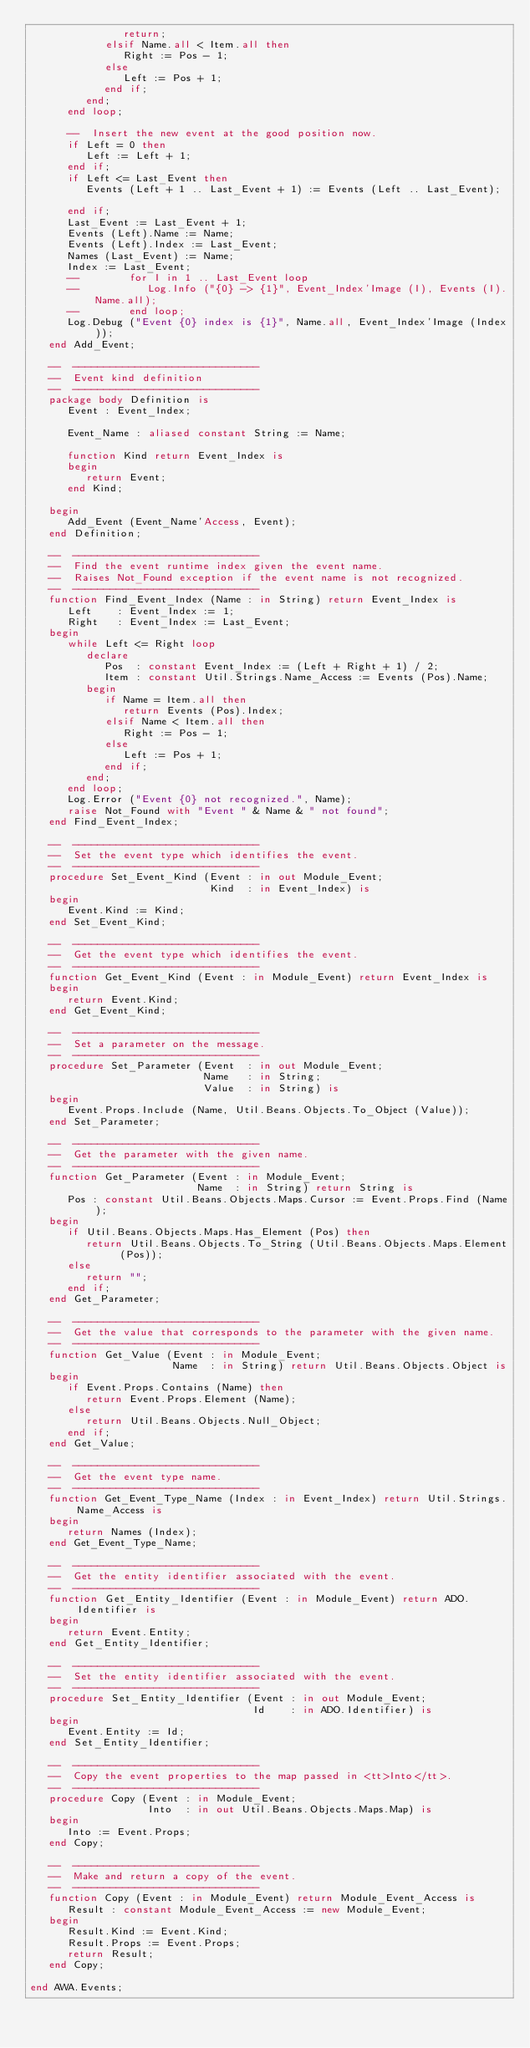<code> <loc_0><loc_0><loc_500><loc_500><_Ada_>               return;
            elsif Name.all < Item.all then
               Right := Pos - 1;
            else
               Left := Pos + 1;
            end if;
         end;
      end loop;

      --  Insert the new event at the good position now.
      if Left = 0 then
         Left := Left + 1;
      end if;
      if Left <= Last_Event then
         Events (Left + 1 .. Last_Event + 1) := Events (Left .. Last_Event);

      end if;
      Last_Event := Last_Event + 1;
      Events (Left).Name := Name;
      Events (Left).Index := Last_Event;
      Names (Last_Event) := Name;
      Index := Last_Event;
      --        for I in 1 .. Last_Event loop
      --           Log.Info ("{0} -> {1}", Event_Index'Image (I), Events (I).Name.all);
      --        end loop;
      Log.Debug ("Event {0} index is {1}", Name.all, Event_Index'Image (Index));
   end Add_Event;

   --  ------------------------------
   --  Event kind definition
   --  ------------------------------
   package body Definition is
      Event : Event_Index;

      Event_Name : aliased constant String := Name;

      function Kind return Event_Index is
      begin
         return Event;
      end Kind;

   begin
      Add_Event (Event_Name'Access, Event);
   end Definition;

   --  ------------------------------
   --  Find the event runtime index given the event name.
   --  Raises Not_Found exception if the event name is not recognized.
   --  ------------------------------
   function Find_Event_Index (Name : in String) return Event_Index is
      Left    : Event_Index := 1;
      Right   : Event_Index := Last_Event;
   begin
      while Left <= Right loop
         declare
            Pos  : constant Event_Index := (Left + Right + 1) / 2;
            Item : constant Util.Strings.Name_Access := Events (Pos).Name;
         begin
            if Name = Item.all then
               return Events (Pos).Index;
            elsif Name < Item.all then
               Right := Pos - 1;
            else
               Left := Pos + 1;
            end if;
         end;
      end loop;
      Log.Error ("Event {0} not recognized.", Name);
      raise Not_Found with "Event " & Name & " not found";
   end Find_Event_Index;

   --  ------------------------------
   --  Set the event type which identifies the event.
   --  ------------------------------
   procedure Set_Event_Kind (Event : in out Module_Event;
                             Kind  : in Event_Index) is
   begin
      Event.Kind := Kind;
   end Set_Event_Kind;

   --  ------------------------------
   --  Get the event type which identifies the event.
   --  ------------------------------
   function Get_Event_Kind (Event : in Module_Event) return Event_Index is
   begin
      return Event.Kind;
   end Get_Event_Kind;

   --  ------------------------------
   --  Set a parameter on the message.
   --  ------------------------------
   procedure Set_Parameter (Event  : in out Module_Event;
                            Name   : in String;
                            Value  : in String) is
   begin
      Event.Props.Include (Name, Util.Beans.Objects.To_Object (Value));
   end Set_Parameter;

   --  ------------------------------
   --  Get the parameter with the given name.
   --  ------------------------------
   function Get_Parameter (Event : in Module_Event;
                           Name  : in String) return String is
      Pos : constant Util.Beans.Objects.Maps.Cursor := Event.Props.Find (Name);
   begin
      if Util.Beans.Objects.Maps.Has_Element (Pos) then
         return Util.Beans.Objects.To_String (Util.Beans.Objects.Maps.Element (Pos));
      else
         return "";
      end if;
   end Get_Parameter;

   --  ------------------------------
   --  Get the value that corresponds to the parameter with the given name.
   --  ------------------------------
   function Get_Value (Event : in Module_Event;
                       Name  : in String) return Util.Beans.Objects.Object is
   begin
      if Event.Props.Contains (Name) then
         return Event.Props.Element (Name);
      else
         return Util.Beans.Objects.Null_Object;
      end if;
   end Get_Value;

   --  ------------------------------
   --  Get the event type name.
   --  ------------------------------
   function Get_Event_Type_Name (Index : in Event_Index) return Util.Strings.Name_Access is
   begin
      return Names (Index);
   end Get_Event_Type_Name;

   --  ------------------------------
   --  Get the entity identifier associated with the event.
   --  ------------------------------
   function Get_Entity_Identifier (Event : in Module_Event) return ADO.Identifier is
   begin
      return Event.Entity;
   end Get_Entity_Identifier;

   --  ------------------------------
   --  Set the entity identifier associated with the event.
   --  ------------------------------
   procedure Set_Entity_Identifier (Event : in out Module_Event;
                                    Id    : in ADO.Identifier) is
   begin
      Event.Entity := Id;
   end Set_Entity_Identifier;

   --  ------------------------------
   --  Copy the event properties to the map passed in <tt>Into</tt>.
   --  ------------------------------
   procedure Copy (Event : in Module_Event;
                   Into  : in out Util.Beans.Objects.Maps.Map) is
   begin
      Into := Event.Props;
   end Copy;

   --  ------------------------------
   --  Make and return a copy of the event.
   --  ------------------------------
   function Copy (Event : in Module_Event) return Module_Event_Access is
      Result : constant Module_Event_Access := new Module_Event;
   begin
      Result.Kind := Event.Kind;
      Result.Props := Event.Props;
      return Result;
   end Copy;

end AWA.Events;
</code> 